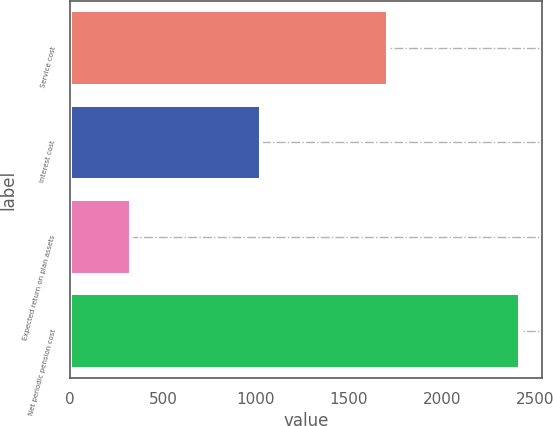Convert chart. <chart><loc_0><loc_0><loc_500><loc_500><bar_chart><fcel>Service cost<fcel>Interest cost<fcel>Expected return on plan assets<fcel>Net periodic pension cost<nl><fcel>1710<fcel>1027<fcel>329<fcel>2419<nl></chart> 